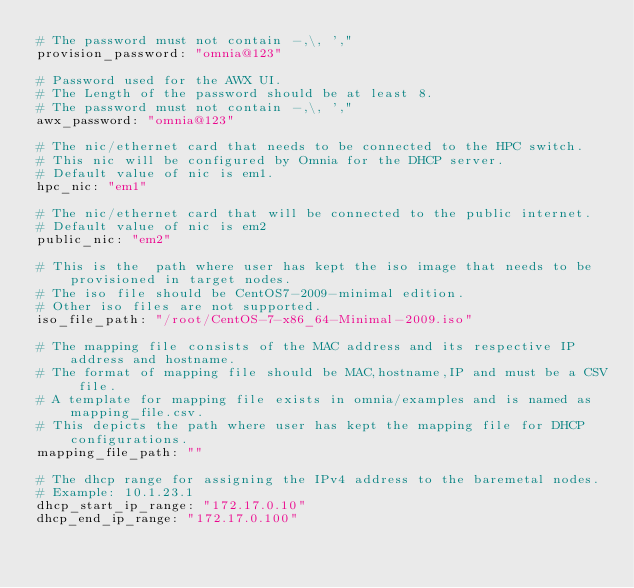<code> <loc_0><loc_0><loc_500><loc_500><_YAML_># The password must not contain -,\, ',"
provision_password: "omnia@123"

# Password used for the AWX UI.
# The Length of the password should be at least 8.
# The password must not contain -,\, ',"
awx_password: "omnia@123"

# The nic/ethernet card that needs to be connected to the HPC switch.
# This nic will be configured by Omnia for the DHCP server.
# Default value of nic is em1.
hpc_nic: "em1"

# The nic/ethernet card that will be connected to the public internet.
# Default value of nic is em2
public_nic: "em2"

# This is the  path where user has kept the iso image that needs to be provisioned in target nodes.
# The iso file should be CentOS7-2009-minimal edition.
# Other iso files are not supported.
iso_file_path: "/root/CentOS-7-x86_64-Minimal-2009.iso"

# The mapping file consists of the MAC address and its respective IP address and hostname.
# The format of mapping file should be MAC,hostname,IP and must be a CSV file.
# A template for mapping file exists in omnia/examples and is named as mapping_file.csv.
# This depicts the path where user has kept the mapping file for DHCP configurations.
mapping_file_path: ""

# The dhcp range for assigning the IPv4 address to the baremetal nodes.
# Example: 10.1.23.1
dhcp_start_ip_range: "172.17.0.10"
dhcp_end_ip_range: "172.17.0.100"
</code> 